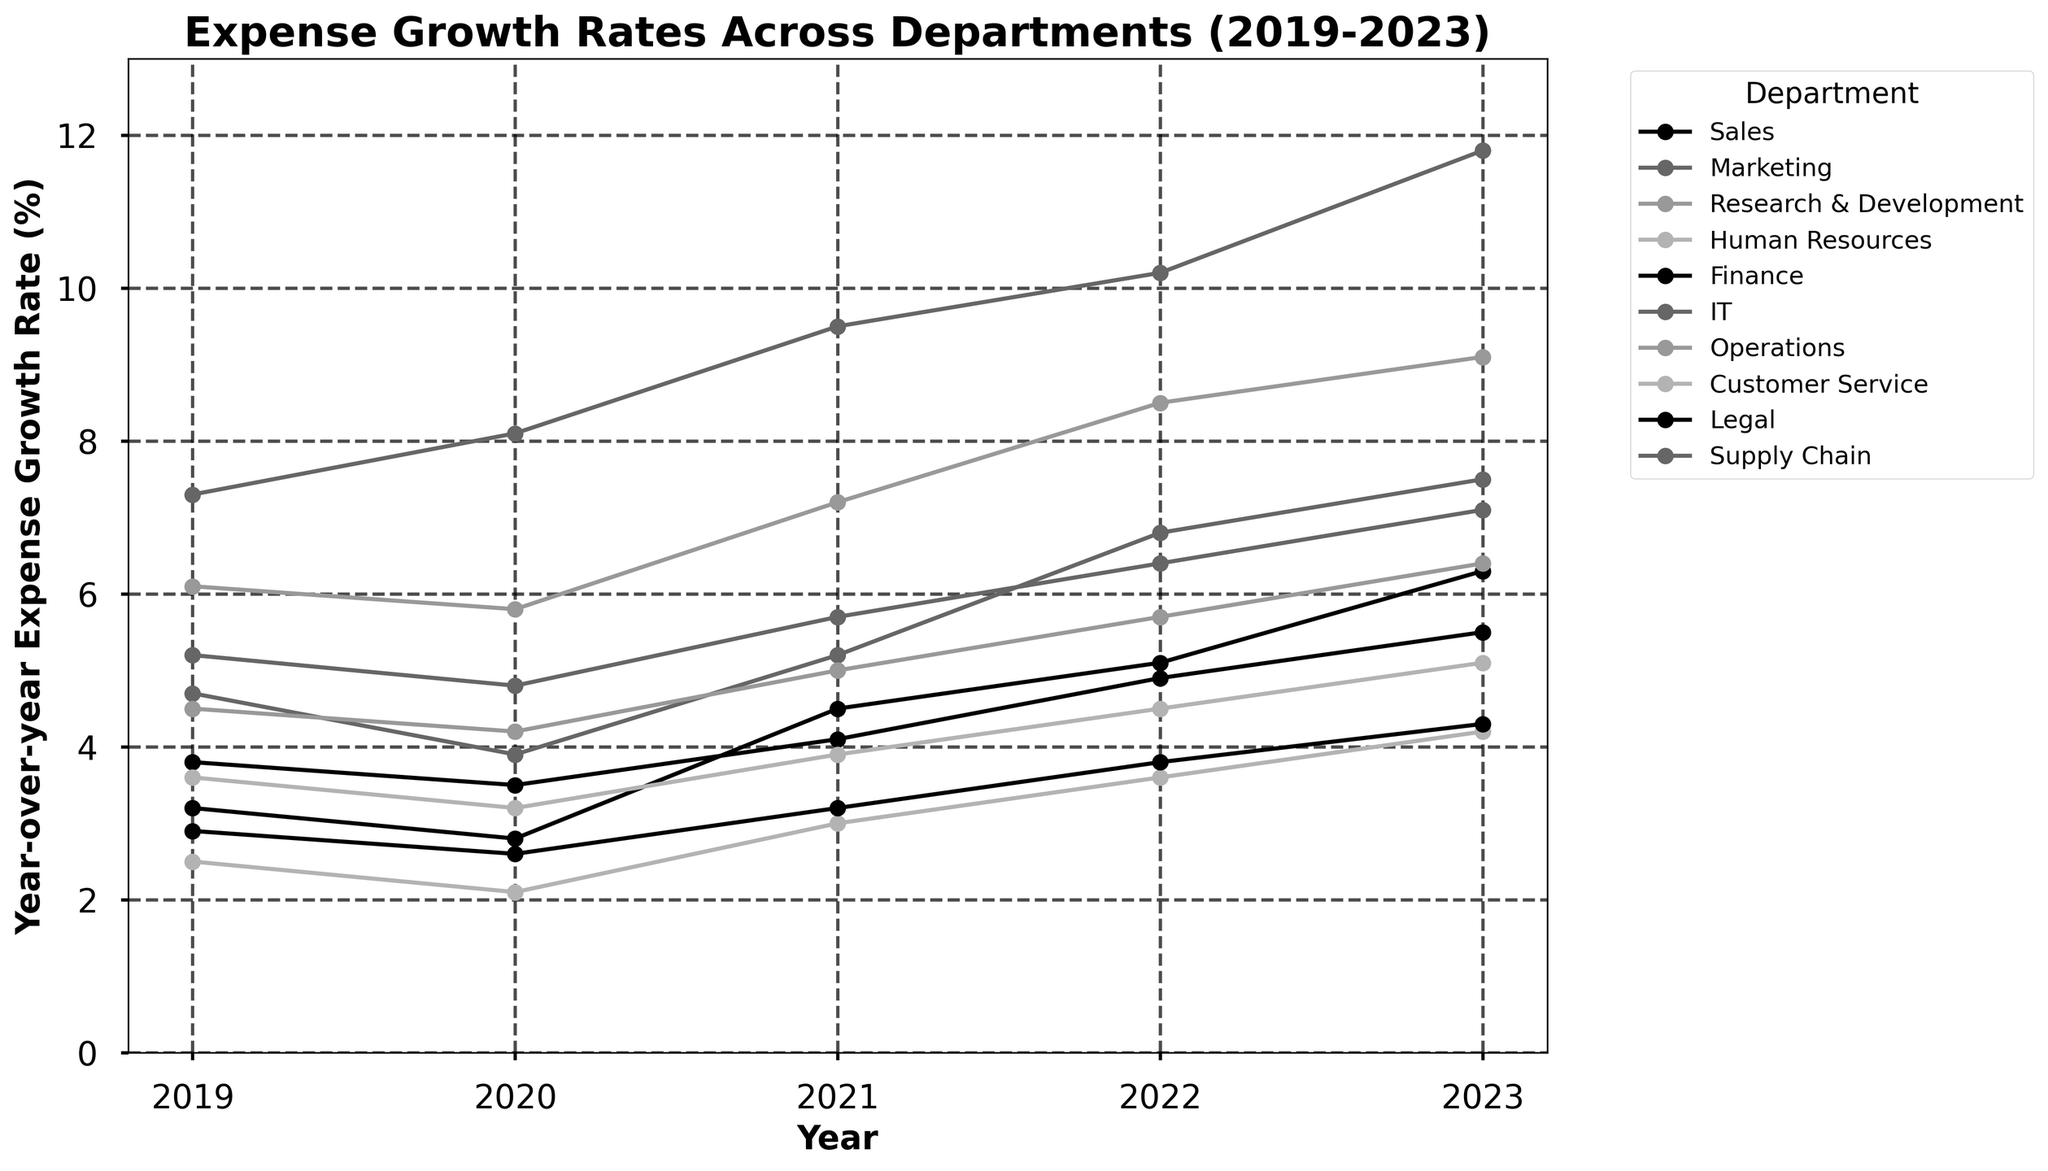Which department had the highest year-over-year expense growth rate in 2023? Look at the data points for 2023 and identify which department has the highest value. IT has the highest value at 11.8%.
Answer: IT Which year did the Sales department experience the highest expense growth rate between 2019 and 2023? Observe the data for the Sales department and identify the highest value between the years. The highest growth rate of 6.3% occurred in 2023.
Answer: 2023 What is the average expense growth rate for the Marketing department from 2019 to 2023? Sum the values for the Marketing department and divide by the number of years (5). (4.7 + 3.9 + 5.2 + 6.8 + 7.5) / 5 = 5.62.
Answer: 5.62 Between Research & Development and Supply Chain, which department had a higher average growth rate between 2019 and 2023? Calculate the average for each department and compare. (6.1 + 5.8 + 7.2 + 8.5 + 9.1)/5 = 7.34 for Research & Development, and (5.2 + 4.8 + 5.7 + 6.4 + 7.1)/5 = 5.84 for Supply Chain.
Answer: Research & Development In which year did HR and IT departments both show a growth rate greater than 10%? Examine the data points for HR and IT for each year and identify the year both values exceed 10%. Only IT exceeds 10% in 2023; HR does not reach 10% in any year.
Answer: None How much higher was the expense growth rate for IT compared to Finance in 2023? Subtract the growth rate of Finance from IT in 2023. 11.8% (IT) - 5.5% (Finance) = 6.3%.
Answer: 6.3% Which department experienced the smallest increase in expense growth rate from 2022 to 2023? Calculate the difference between 2022 and 2023 for each department and identify the smallest increase. Legal: 4.3 - 3.8 = 0.5%.
Answer: Legal What is the total growth rate in 2021 for Sales, Marketing, and Finance combined? Add the 2021 values for Sales, Marketing, and Finance. 4.5% (Sales) + 5.2% (Marketing) + 4.1% (Finance) = 13.8%.
Answer: 13.8% Which two departments had the closest expense growth rates in 2022? Observe the 2022 data points and find the two departments with the smallest difference. Finance (4.9%) and Customer Service (4.5%) differ by only 0.4%.
Answer: Finance and Customer Service 